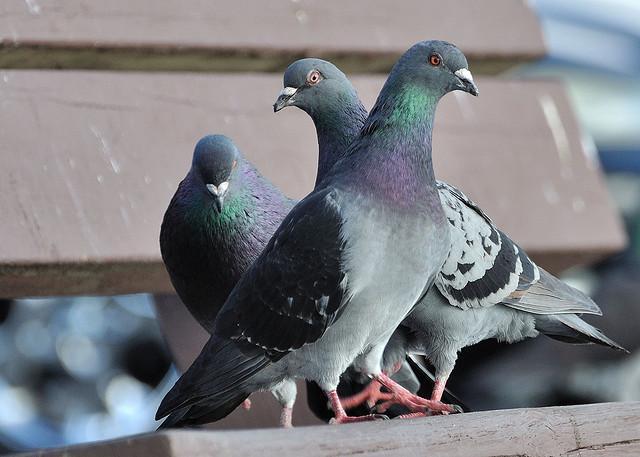How many birds are there?
Give a very brief answer. 3. How many birds are in the photo?
Give a very brief answer. 3. 